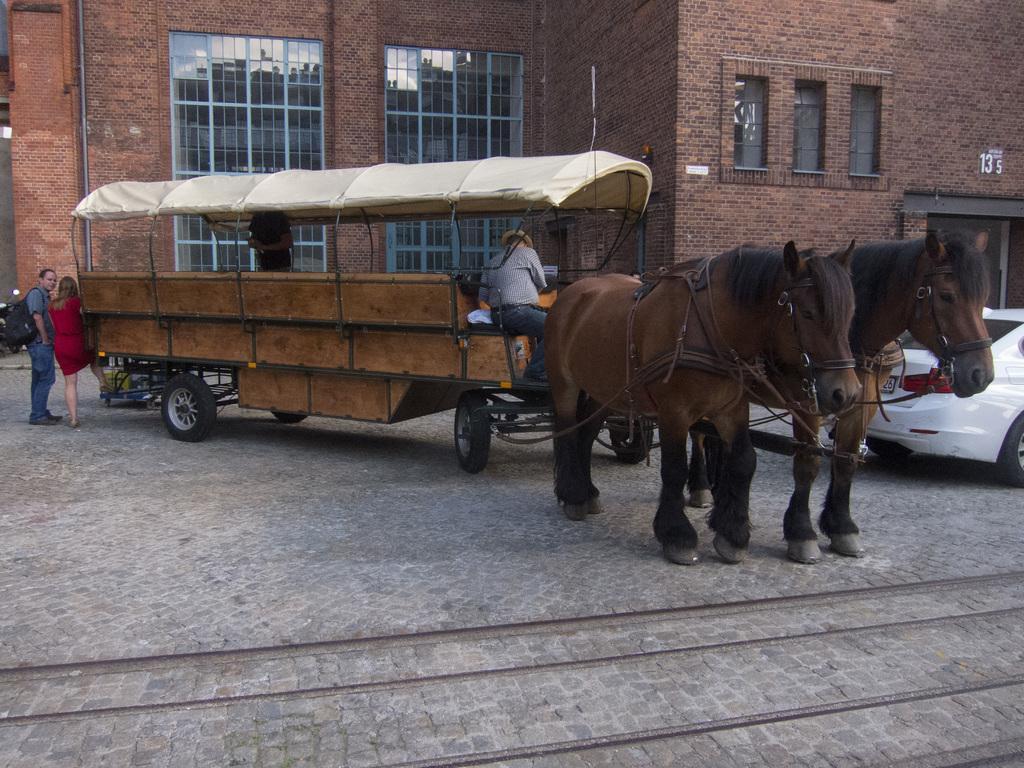Could you give a brief overview of what you see in this image? In this image we can see some people in a horse cart. We can also see a car and some people standing on the ground. On the backside we can see a building with windows. 